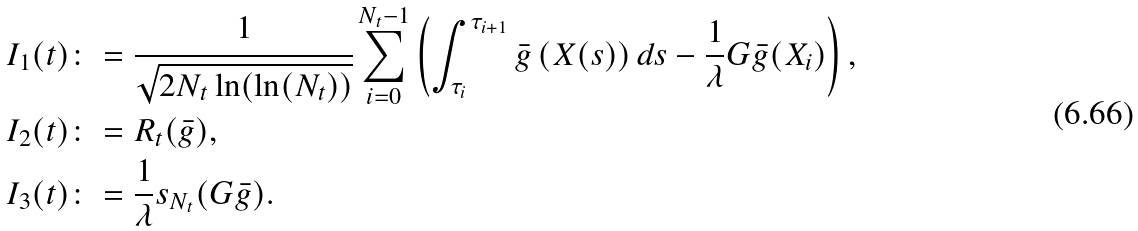Convert formula to latex. <formula><loc_0><loc_0><loc_500><loc_500>& I _ { 1 } ( t ) \colon = \cfrac { 1 } { \sqrt { 2 N _ { t } \ln ( \ln ( N _ { t } ) ) } } \sum _ { i = 0 } ^ { N _ { t } - 1 } \left ( \int _ { \tau _ { i } } ^ { \tau _ { i + 1 } } \bar { g } \left ( X ( s ) \right ) d s - \frac { 1 } { \lambda } G \bar { g } ( X _ { i } ) \right ) , \\ & I _ { 2 } ( t ) \colon = R _ { t } ( \bar { g } ) , \\ & I _ { 3 } ( t ) \colon = \frac { 1 } { \lambda } s _ { N _ { t } } ( G \bar { g } ) .</formula> 